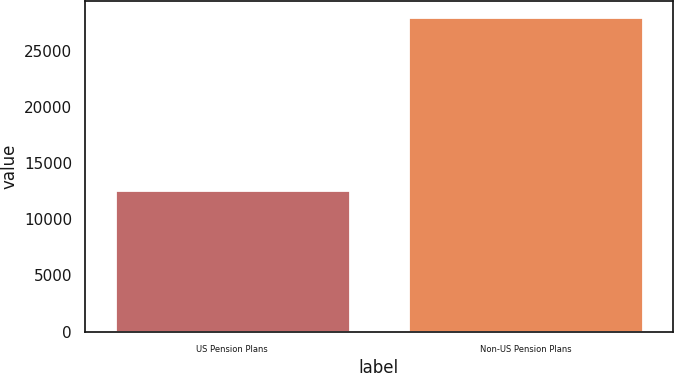Convert chart to OTSL. <chart><loc_0><loc_0><loc_500><loc_500><bar_chart><fcel>US Pension Plans<fcel>Non-US Pension Plans<nl><fcel>12563<fcel>28023<nl></chart> 